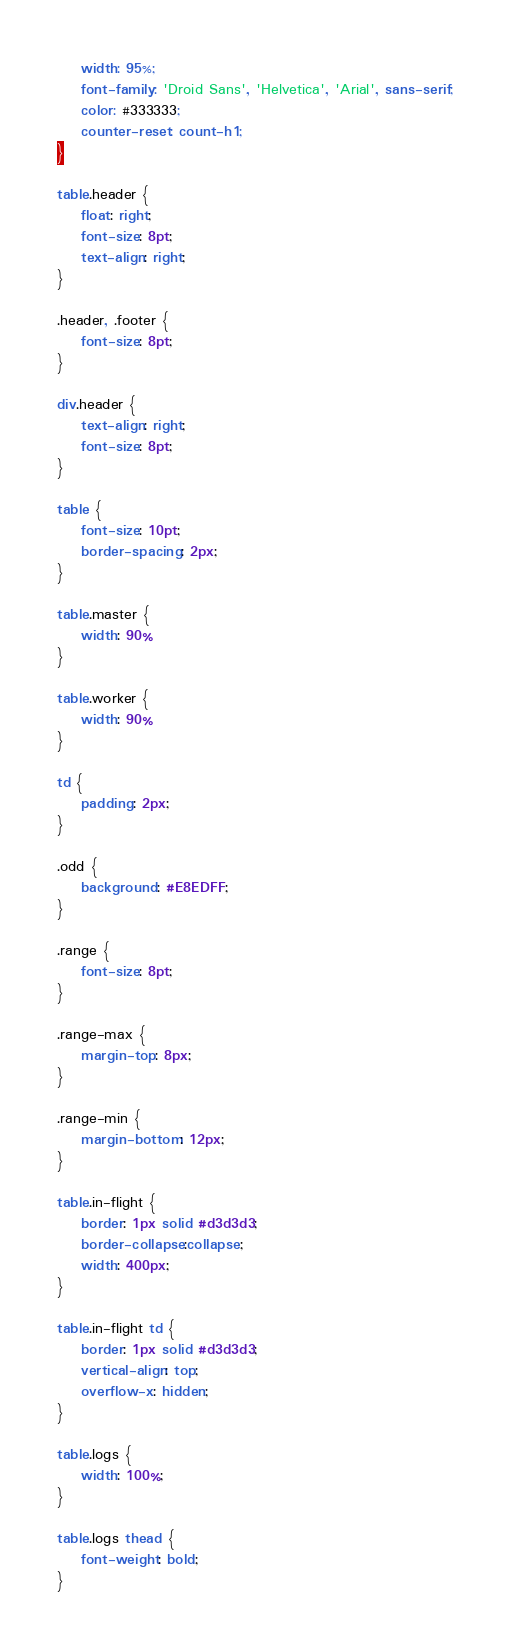Convert code to text. <code><loc_0><loc_0><loc_500><loc_500><_CSS_>    width: 95%;
    font-family: 'Droid Sans', 'Helvetica', 'Arial', sans-serif;
    color: #333333;
    counter-reset: count-h1;
}

table.header {
    float: right;
    font-size: 8pt;
    text-align: right;
}

.header, .footer {
    font-size: 8pt;
}

div.header {
    text-align: right;
    font-size: 8pt;
}

table {
    font-size: 10pt;
    border-spacing: 2px;
}

table.master {
    width: 90%
}

table.worker {
    width: 90%
}

td {
    padding: 2px;
}

.odd {
    background: #E8EDFF;
}

.range {
    font-size: 8pt;
}

.range-max {
    margin-top: 8px;
}

.range-min {
    margin-bottom: 12px;
}

table.in-flight {
    border: 1px solid #d3d3d3;
    border-collapse:collapse;
    width: 400px;
}

table.in-flight td {
    border: 1px solid #d3d3d3;
    vertical-align: top;
    overflow-x: hidden;
}

table.logs {
    width: 100%;
}

table.logs thead {
    font-weight: bold;
}</code> 